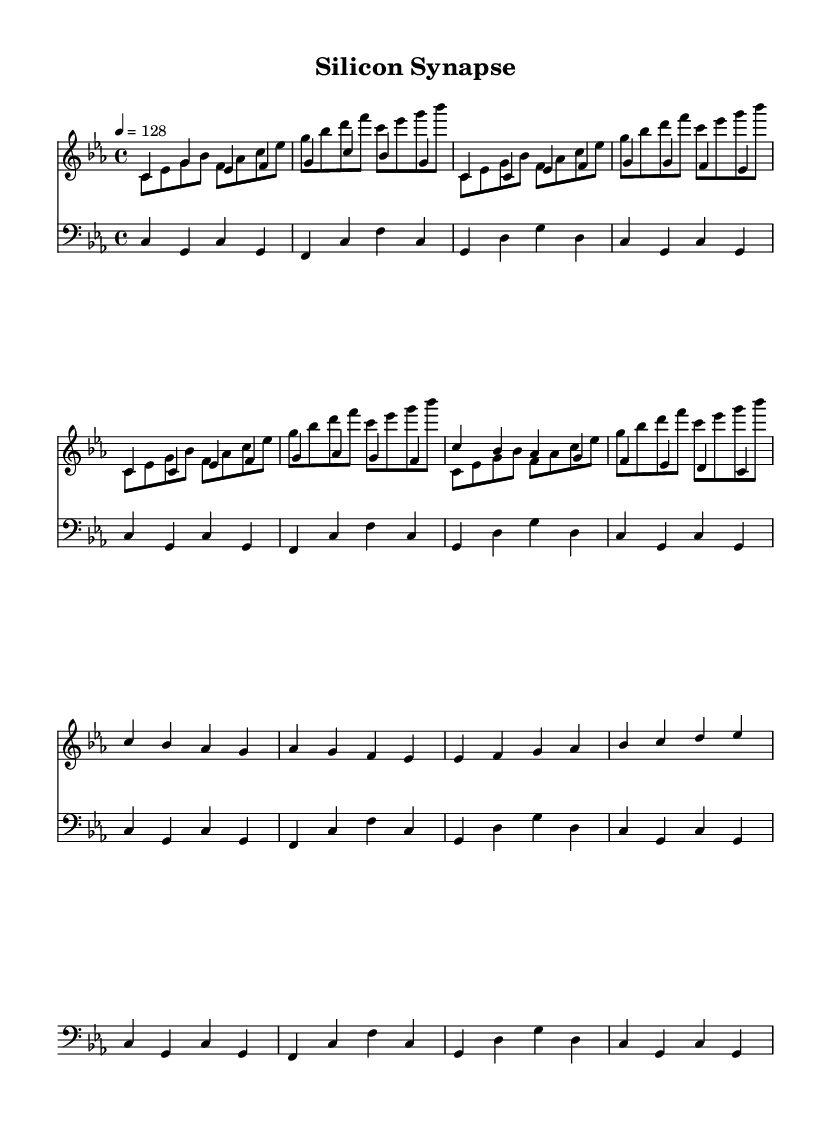what is the key signature of this music? The key signature is indicated by the sharp and flat symbols in the beginning of the staff. In this piece, there are no sharps or flats, which means it is in C minor.
Answer: C minor what is the time signature of this music? The time signature is indicated at the beginning of the score. In this case, it shows 4/4, meaning there are four beats per measure, and the quarter note gets one beat.
Answer: 4/4 what is the tempo marking of this piece? The tempo is found in the score where it states "4 = 128," which means that a quarter note is played at a speed of 128 beats per minute.
Answer: 128 how many measures are in the intro section? The intro section consists of 2 measures as identified at the beginning of the piece where the notes are grouped.
Answer: 2 which instrument plays the lead melody? The lead melody is indicated by the voice labeled "synthLead." This specifies that the synthesizer is responsible for the main melodic line.
Answer: synthLead how does the bass synth pattern vary from the synth lead? The bass synth pattern primarily utilizes whole notes and a consistent rhythm in contrast to the syncopated and varied rhythm of the synth lead melody. The bass plays foundational harmonic notes while the lead plays melodic phrases.
Answer: Repetitive vs. Melodic what is the structure of this song regarding the sections introduced? The song follows a structure of Intro, Verse, Chorus, and Bridge as identified by the different musical patterns. Each section is clearly laid out and defined in the score.
Answer: Intro, Verse, Chorus, Bridge 